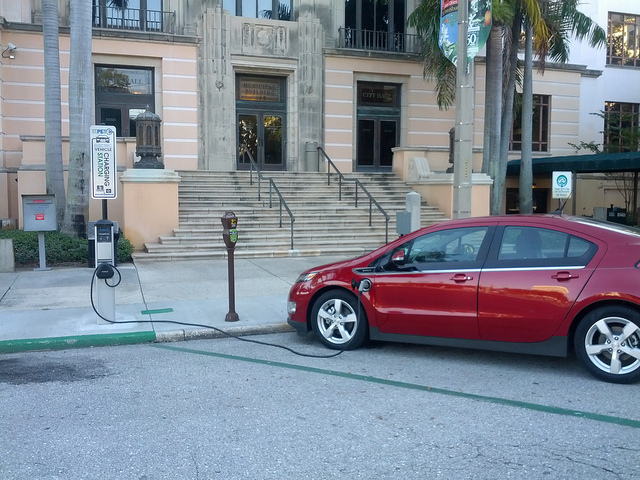Identify and read out the text in this image. CHARGING 60 